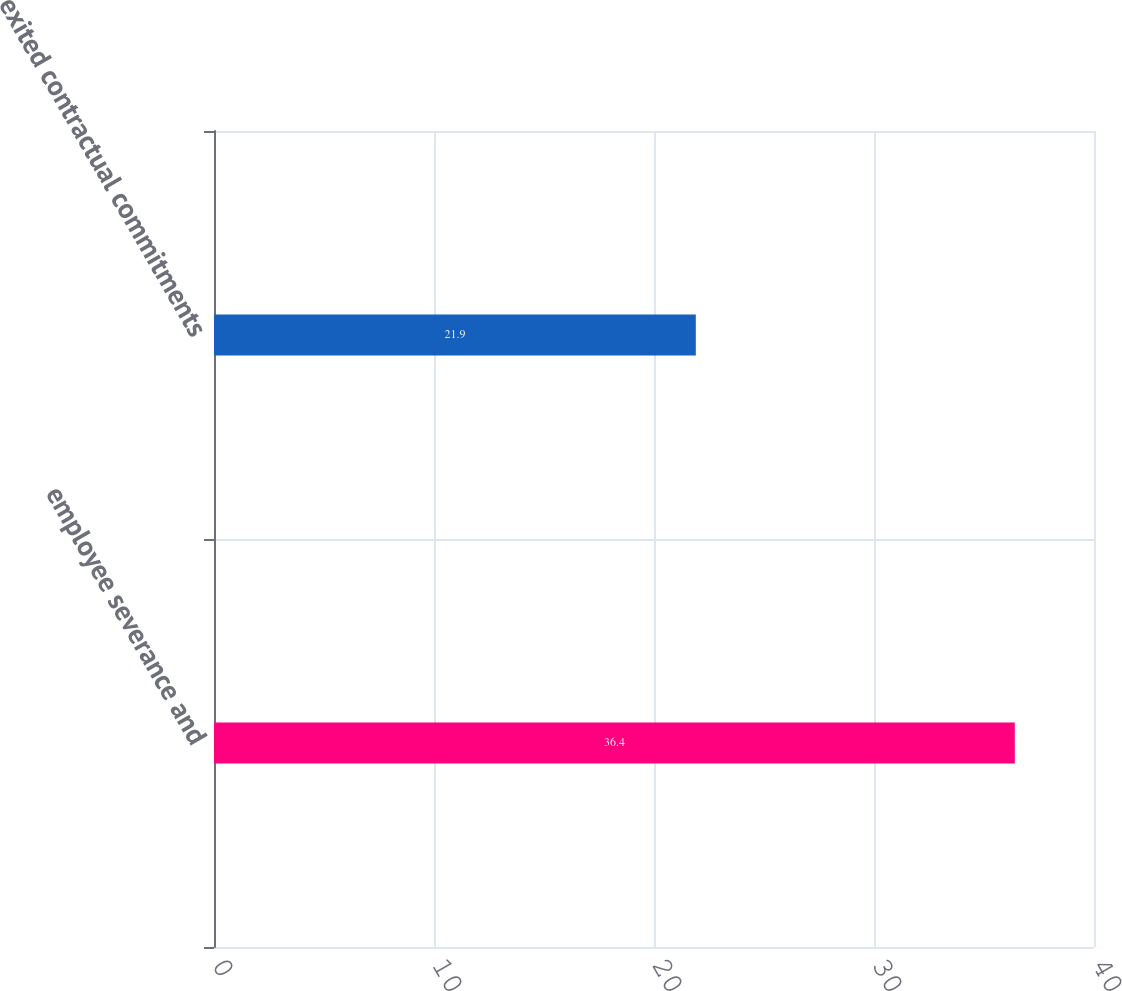Convert chart. <chart><loc_0><loc_0><loc_500><loc_500><bar_chart><fcel>employee severance and<fcel>exited contractual commitments<nl><fcel>36.4<fcel>21.9<nl></chart> 